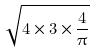Convert formula to latex. <formula><loc_0><loc_0><loc_500><loc_500>\sqrt { 4 \times 3 \times \frac { 4 } { \pi } }</formula> 